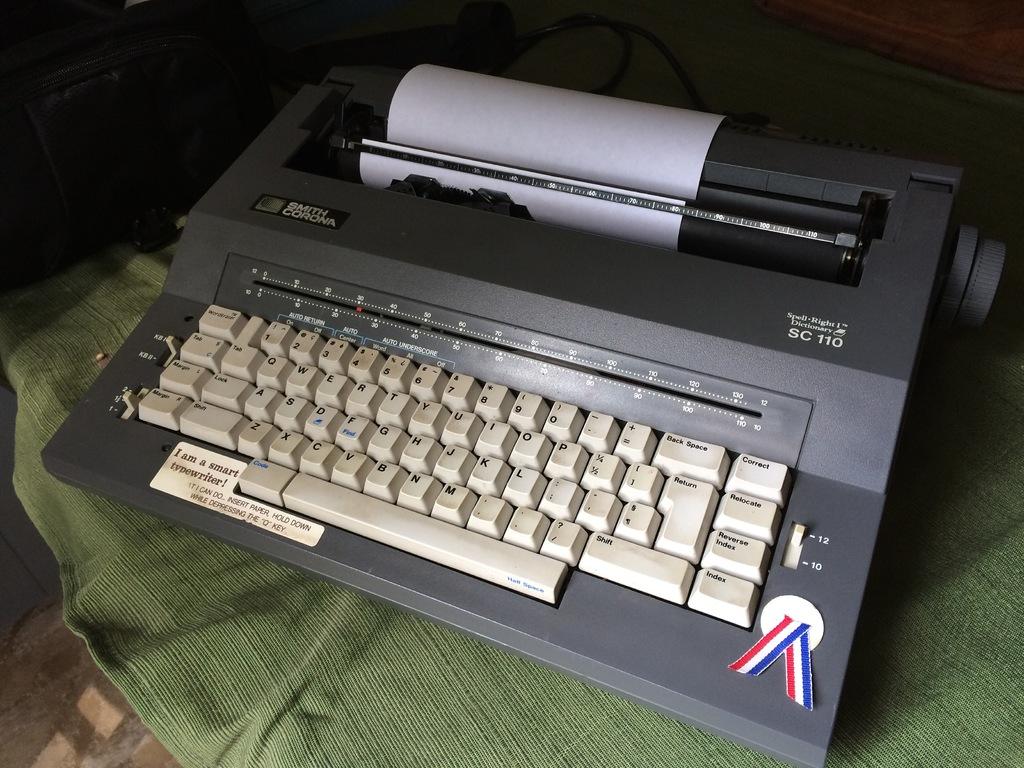What brand of type writer is this?
Your answer should be very brief. Smith corona. What number follows sc?
Give a very brief answer. 110. 